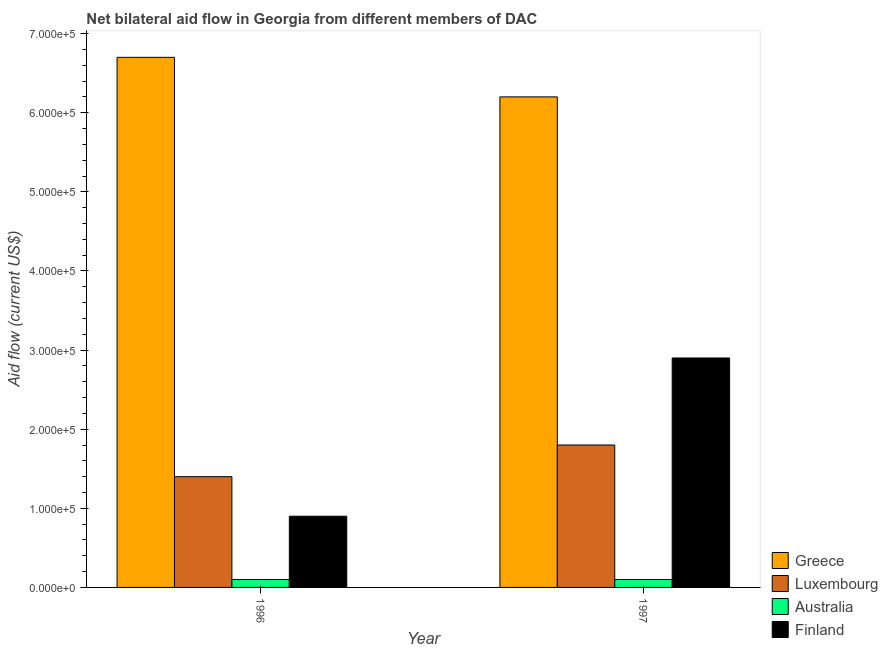How many different coloured bars are there?
Your answer should be compact. 4. How many groups of bars are there?
Ensure brevity in your answer.  2. Are the number of bars per tick equal to the number of legend labels?
Ensure brevity in your answer.  Yes. Are the number of bars on each tick of the X-axis equal?
Provide a succinct answer. Yes. How many bars are there on the 2nd tick from the left?
Ensure brevity in your answer.  4. What is the amount of aid given by greece in 1996?
Your answer should be very brief. 6.70e+05. Across all years, what is the maximum amount of aid given by luxembourg?
Your answer should be compact. 1.80e+05. Across all years, what is the minimum amount of aid given by luxembourg?
Make the answer very short. 1.40e+05. In which year was the amount of aid given by finland maximum?
Keep it short and to the point. 1997. In which year was the amount of aid given by luxembourg minimum?
Give a very brief answer. 1996. What is the total amount of aid given by australia in the graph?
Make the answer very short. 2.00e+04. What is the difference between the amount of aid given by greece in 1996 and that in 1997?
Keep it short and to the point. 5.00e+04. In the year 1997, what is the difference between the amount of aid given by greece and amount of aid given by finland?
Offer a very short reply. 0. What is the ratio of the amount of aid given by finland in 1996 to that in 1997?
Provide a short and direct response. 0.31. What does the 3rd bar from the left in 1996 represents?
Your response must be concise. Australia. How many bars are there?
Your response must be concise. 8. How many years are there in the graph?
Keep it short and to the point. 2. Does the graph contain any zero values?
Your answer should be compact. No. Does the graph contain grids?
Offer a very short reply. No. How many legend labels are there?
Provide a succinct answer. 4. How are the legend labels stacked?
Provide a succinct answer. Vertical. What is the title of the graph?
Provide a short and direct response. Net bilateral aid flow in Georgia from different members of DAC. Does "Tertiary education" appear as one of the legend labels in the graph?
Provide a short and direct response. No. What is the Aid flow (current US$) in Greece in 1996?
Offer a terse response. 6.70e+05. What is the Aid flow (current US$) of Greece in 1997?
Your answer should be compact. 6.20e+05. What is the Aid flow (current US$) of Luxembourg in 1997?
Make the answer very short. 1.80e+05. What is the Aid flow (current US$) in Finland in 1997?
Keep it short and to the point. 2.90e+05. Across all years, what is the maximum Aid flow (current US$) in Greece?
Give a very brief answer. 6.70e+05. Across all years, what is the maximum Aid flow (current US$) in Australia?
Offer a very short reply. 10000. Across all years, what is the minimum Aid flow (current US$) in Greece?
Provide a succinct answer. 6.20e+05. Across all years, what is the minimum Aid flow (current US$) of Luxembourg?
Offer a terse response. 1.40e+05. Across all years, what is the minimum Aid flow (current US$) in Australia?
Offer a terse response. 10000. What is the total Aid flow (current US$) in Greece in the graph?
Offer a terse response. 1.29e+06. What is the difference between the Aid flow (current US$) in Greece in 1996 and the Aid flow (current US$) in Luxembourg in 1997?
Offer a very short reply. 4.90e+05. What is the difference between the Aid flow (current US$) in Luxembourg in 1996 and the Aid flow (current US$) in Finland in 1997?
Offer a terse response. -1.50e+05. What is the difference between the Aid flow (current US$) of Australia in 1996 and the Aid flow (current US$) of Finland in 1997?
Your answer should be very brief. -2.80e+05. What is the average Aid flow (current US$) in Greece per year?
Offer a very short reply. 6.45e+05. What is the average Aid flow (current US$) of Luxembourg per year?
Keep it short and to the point. 1.60e+05. What is the average Aid flow (current US$) in Australia per year?
Keep it short and to the point. 10000. In the year 1996, what is the difference between the Aid flow (current US$) in Greece and Aid flow (current US$) in Luxembourg?
Ensure brevity in your answer.  5.30e+05. In the year 1996, what is the difference between the Aid flow (current US$) of Greece and Aid flow (current US$) of Australia?
Provide a short and direct response. 6.60e+05. In the year 1996, what is the difference between the Aid flow (current US$) of Greece and Aid flow (current US$) of Finland?
Ensure brevity in your answer.  5.80e+05. In the year 1996, what is the difference between the Aid flow (current US$) in Luxembourg and Aid flow (current US$) in Australia?
Your answer should be compact. 1.30e+05. In the year 1996, what is the difference between the Aid flow (current US$) in Luxembourg and Aid flow (current US$) in Finland?
Your answer should be very brief. 5.00e+04. In the year 1997, what is the difference between the Aid flow (current US$) in Greece and Aid flow (current US$) in Luxembourg?
Your response must be concise. 4.40e+05. In the year 1997, what is the difference between the Aid flow (current US$) in Greece and Aid flow (current US$) in Finland?
Provide a succinct answer. 3.30e+05. In the year 1997, what is the difference between the Aid flow (current US$) in Luxembourg and Aid flow (current US$) in Australia?
Provide a short and direct response. 1.70e+05. In the year 1997, what is the difference between the Aid flow (current US$) of Luxembourg and Aid flow (current US$) of Finland?
Ensure brevity in your answer.  -1.10e+05. In the year 1997, what is the difference between the Aid flow (current US$) in Australia and Aid flow (current US$) in Finland?
Make the answer very short. -2.80e+05. What is the ratio of the Aid flow (current US$) in Greece in 1996 to that in 1997?
Your answer should be compact. 1.08. What is the ratio of the Aid flow (current US$) in Luxembourg in 1996 to that in 1997?
Give a very brief answer. 0.78. What is the ratio of the Aid flow (current US$) of Finland in 1996 to that in 1997?
Give a very brief answer. 0.31. What is the difference between the highest and the second highest Aid flow (current US$) of Luxembourg?
Keep it short and to the point. 4.00e+04. What is the difference between the highest and the second highest Aid flow (current US$) in Finland?
Your response must be concise. 2.00e+05. What is the difference between the highest and the lowest Aid flow (current US$) of Australia?
Your answer should be compact. 0. What is the difference between the highest and the lowest Aid flow (current US$) of Finland?
Provide a short and direct response. 2.00e+05. 